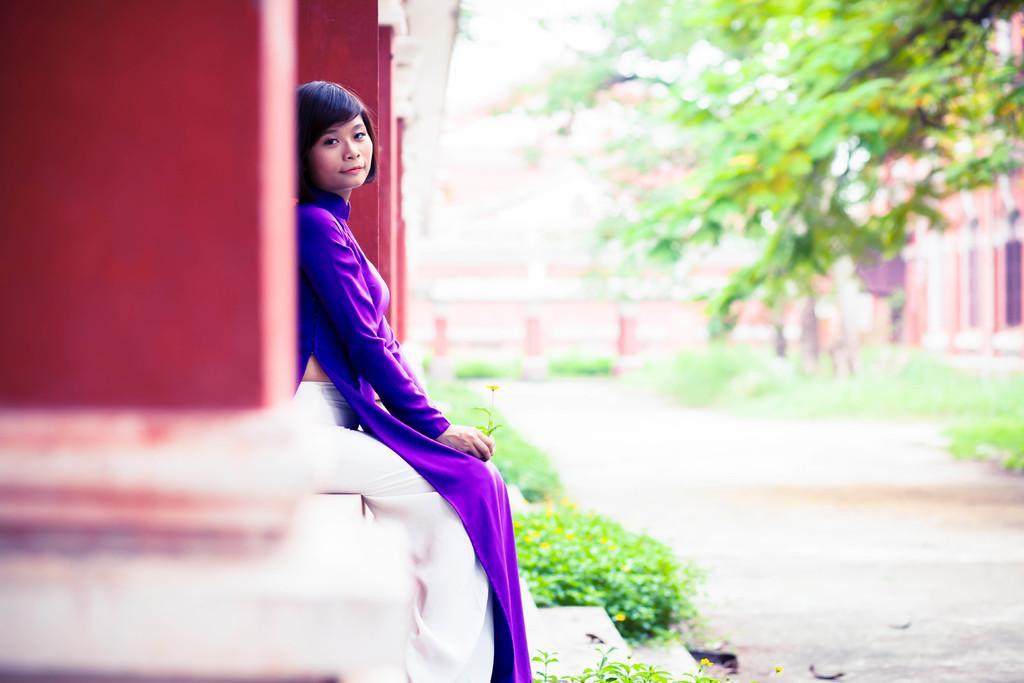Could you give a brief overview of what you see in this image? In this image I can see a person and the person is wearing purple and white color dress. Background I can see few pillars in red color, trees in green color, a building and the sky is in white color. 